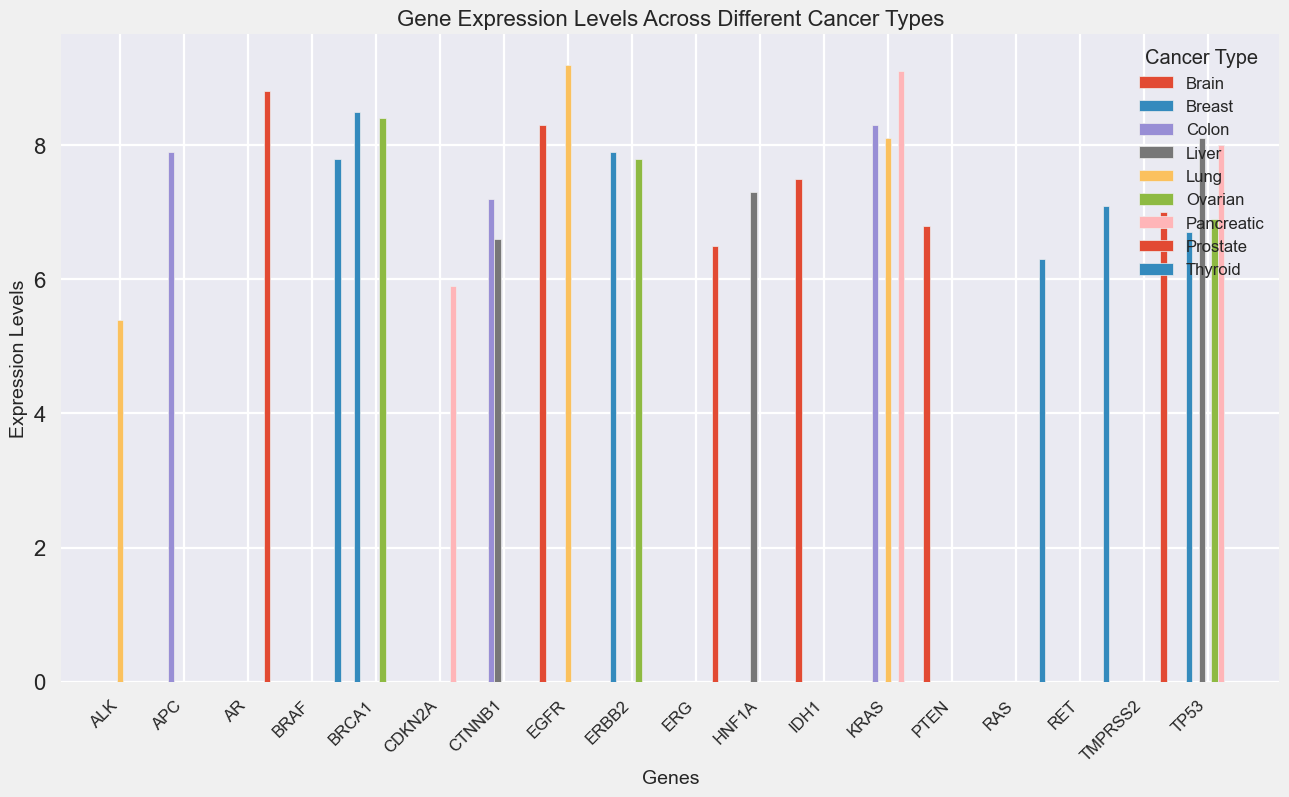Which cancer type has the highest expression of KRAS? Visual comparison shows that KRAS has the highest bar in Lung cancer compared to other cancer types.
Answer: Lung What is the difference in expression levels of TP53 between Breast and Liver cancer? The expression level of TP53 in Breast cancer is 6.7, and in Liver cancer, it is 8.1. Subtracting these, we get 8.1 - 6.7 = 1.4.
Answer: 1.4 Which gene has the highest expression level in Pancreatic cancer, and what is that level? By visually comparing the heights of the bars in Pancreatic cancer, KRAS has the highest expression level at 9.1.
Answer: KRAS, 9.1 Among genes BRCA1, TP53, and ERBB2, which one has the lowest average expression level across all cancer types? Calculating the average expression levels:  
BRCA1: (8.5 + 8.4)/2 = 8.45  
TP53: (6.7 + 6.9 + 8.0 + 8.1)/4 = 7.425  
ERBB2: (7.9 + 7.8)/2 = 7.85  
TP53 has the lowest average.
Answer: TP53 In which cancer type does the gene EGFR have the highest expression level? By comparing the heights of the bars for EGFR in all cancer types, the highest bar is in Lung cancer at 9.2.
Answer: Lung How does the expression level of APC in Colon cancer compare to the expression level of HNF1A in Liver cancer? By visual comparison, APC in Colon cancer has an expression level of 7.9, and HNF1A in Liver cancer has an expression level of 7.3. Since 7.9 > 7.3, APC is higher.
Answer: APC is higher What is the sum of expression levels of genes in Brain cancer? Adding the levels: EGFR (8.3), PTEN (6.8), IDH1 (7.5) gives 8.3 + 6.8 + 7.5 = 22.6.
Answer: 22.6 Is there any cancer type where the expression of KRAS is equal to the expression level of any other gene? Comparing KRAS expression levels (8.1 in Lung, 8.3 in Colon, 9.1 in Pancreatic) to other genes, none match these values exactly.
Answer: No Which gene has the lowest expression level in Thyroid cancer? By visual comparison of bar heights in Thyroid cancer, RAS has the lowest expression level at 6.3.
Answer: RAS What is the average expression level of the six genes in Breast cancer? Summing expression levels of BRCA1 (8.5), TP53 (6.7), ERBB2 (7.9) and dividing by 3 gives (8.5 + 6.7 + 7.9)/3 = 7.7.
Answer: 7.7 